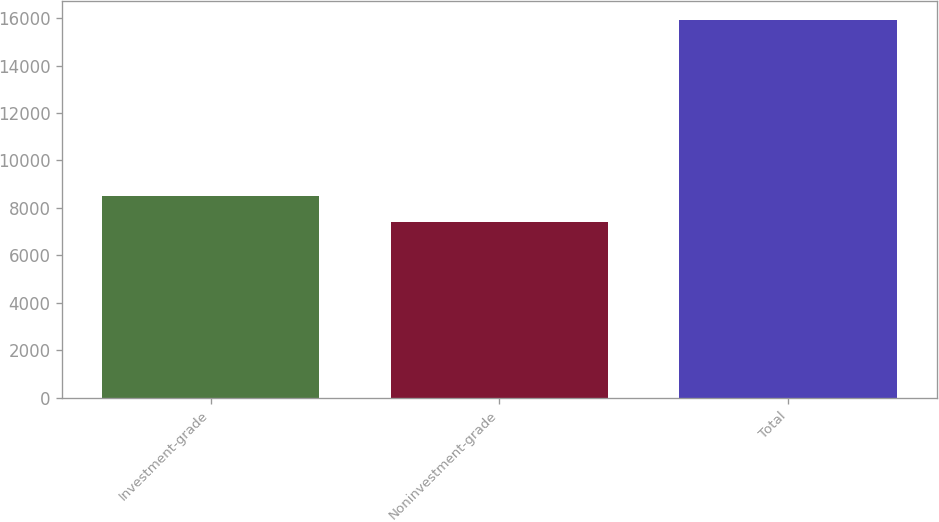<chart> <loc_0><loc_0><loc_500><loc_500><bar_chart><fcel>Investment-grade<fcel>Noninvestment-grade<fcel>Total<nl><fcel>8516<fcel>7407<fcel>15923<nl></chart> 